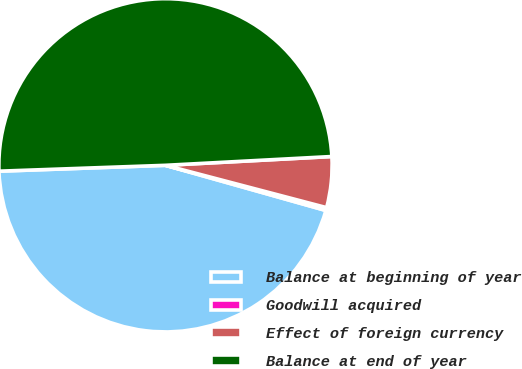Convert chart to OTSL. <chart><loc_0><loc_0><loc_500><loc_500><pie_chart><fcel>Balance at beginning of year<fcel>Goodwill acquired<fcel>Effect of foreign currency<fcel>Balance at end of year<nl><fcel>45.07%<fcel>0.28%<fcel>4.93%<fcel>49.72%<nl></chart> 